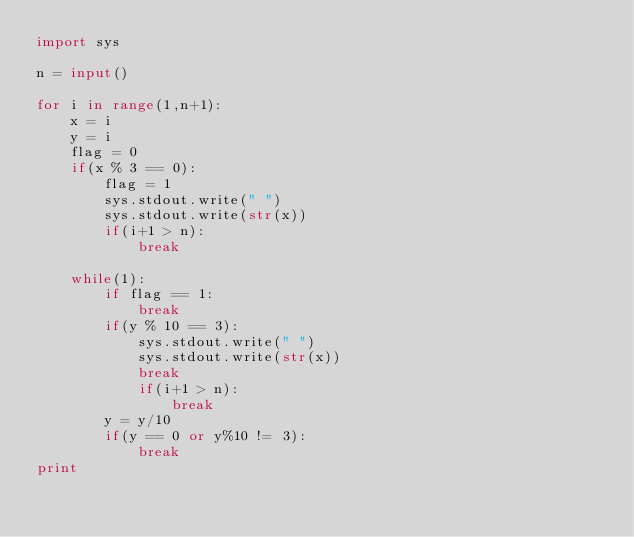<code> <loc_0><loc_0><loc_500><loc_500><_Python_>import sys

n = input()

for i in range(1,n+1):
    x = i
    y = i
    flag = 0
    if(x % 3 == 0):
        flag = 1
        sys.stdout.write(" ")
        sys.stdout.write(str(x))
        if(i+1 > n):
            break

    while(1):
        if flag == 1:
            break
        if(y % 10 == 3):
            sys.stdout.write(" ")
            sys.stdout.write(str(x))
            break
            if(i+1 > n):
                break
        y = y/10
        if(y == 0 or y%10 != 3):
            break
print</code> 